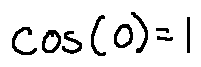Convert formula to latex. <formula><loc_0><loc_0><loc_500><loc_500>\cos ( 0 ) = 1</formula> 